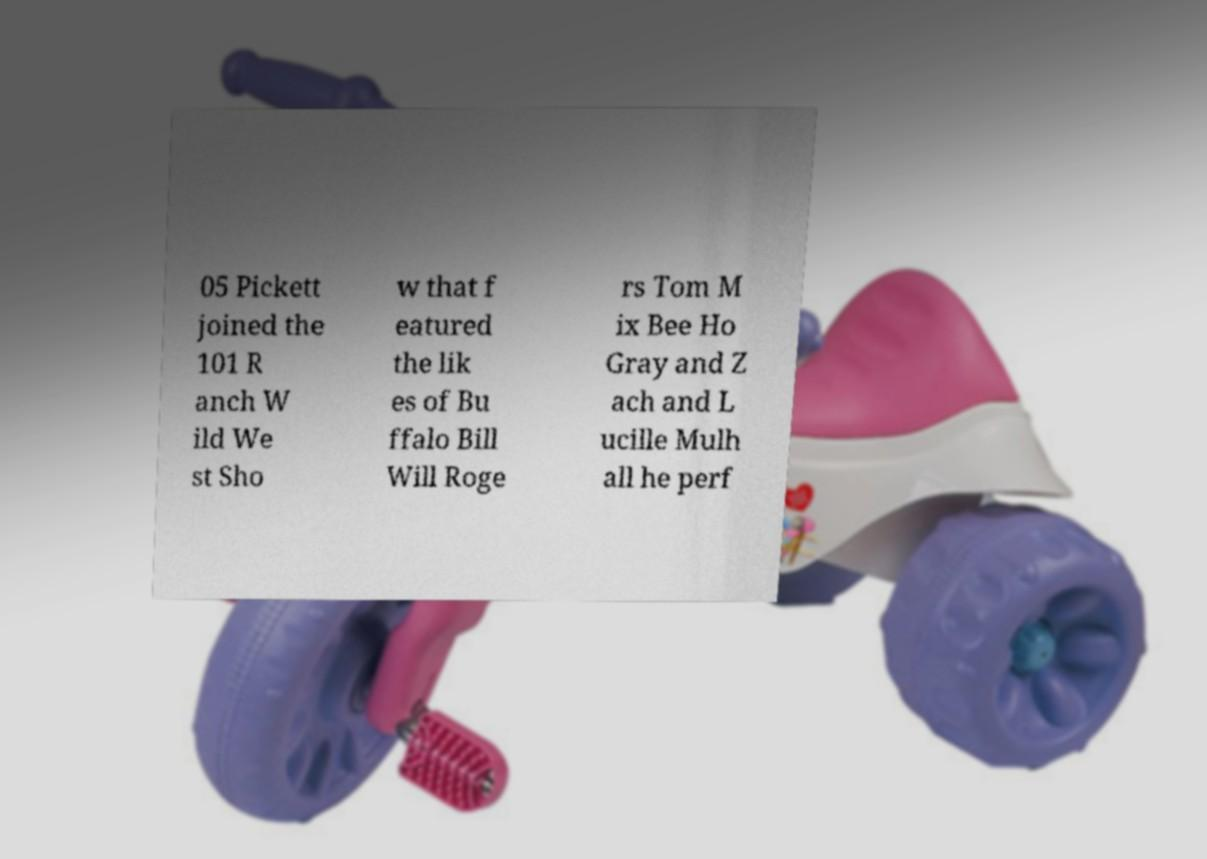I need the written content from this picture converted into text. Can you do that? 05 Pickett joined the 101 R anch W ild We st Sho w that f eatured the lik es of Bu ffalo Bill Will Roge rs Tom M ix Bee Ho Gray and Z ach and L ucille Mulh all he perf 